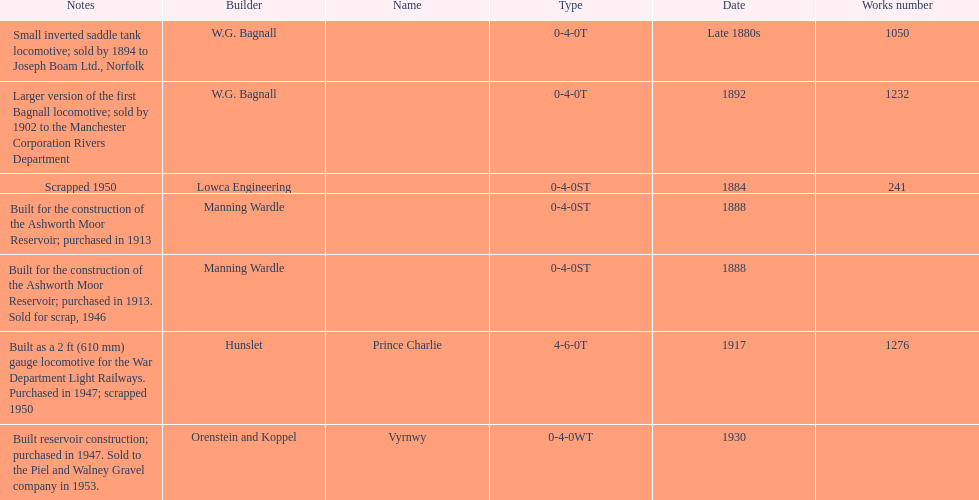How many locomotives were built before the 1900s? 5. 